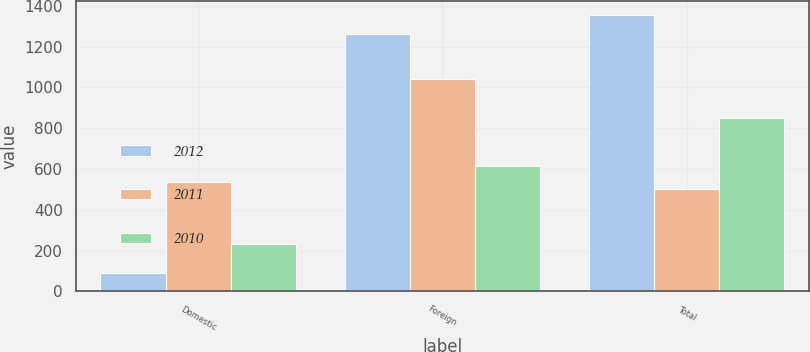Convert chart. <chart><loc_0><loc_0><loc_500><loc_500><stacked_bar_chart><ecel><fcel>Domestic<fcel>Foreign<fcel>Total<nl><fcel>2012<fcel>92<fcel>1264<fcel>1356<nl><fcel>2011<fcel>537<fcel>1039<fcel>502<nl><fcel>2010<fcel>234<fcel>614<fcel>848<nl></chart> 